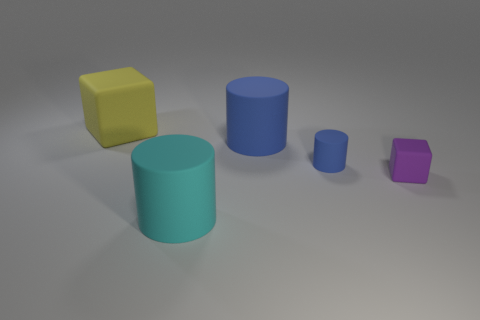What is the material of the tiny object that is behind the small purple cube?
Provide a succinct answer. Rubber. Does the yellow rubber object have the same shape as the matte object right of the small blue rubber cylinder?
Offer a very short reply. Yes. What number of purple matte cubes are in front of the tiny blue matte cylinder right of the big cylinder that is behind the small rubber cylinder?
Make the answer very short. 1. There is a tiny rubber object that is the same shape as the large yellow matte thing; what is its color?
Ensure brevity in your answer.  Purple. Is there anything else that is the same shape as the yellow thing?
Offer a terse response. Yes. How many cubes are either big matte things or purple rubber objects?
Offer a very short reply. 2. The big cyan thing has what shape?
Your answer should be very brief. Cylinder. Are there any blue things left of the large cyan cylinder?
Ensure brevity in your answer.  No. Is the small purple object made of the same material as the big yellow object that is on the left side of the tiny blue object?
Your answer should be very brief. Yes. Is the shape of the tiny matte thing in front of the small blue cylinder the same as  the big cyan matte thing?
Ensure brevity in your answer.  No. 